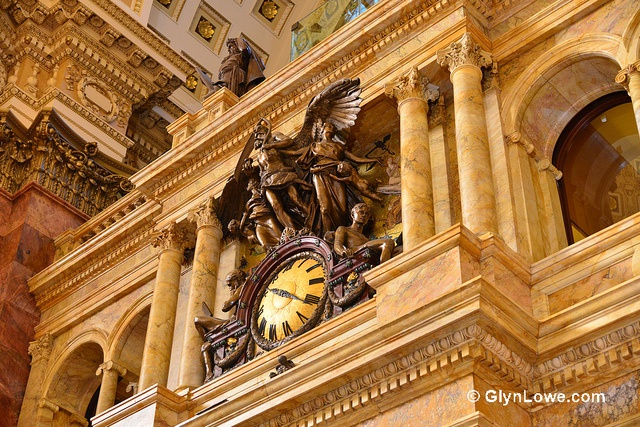Describe the objects in this image and their specific colors. I can see a clock in maroon, gold, black, and khaki tones in this image. 